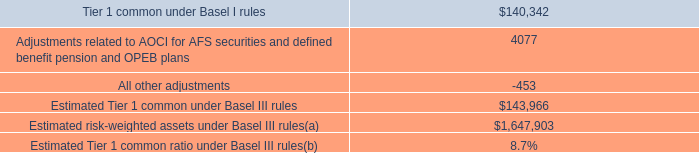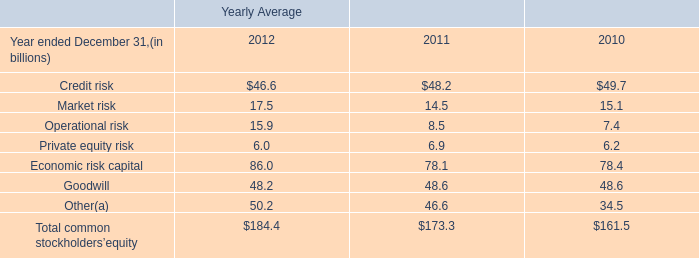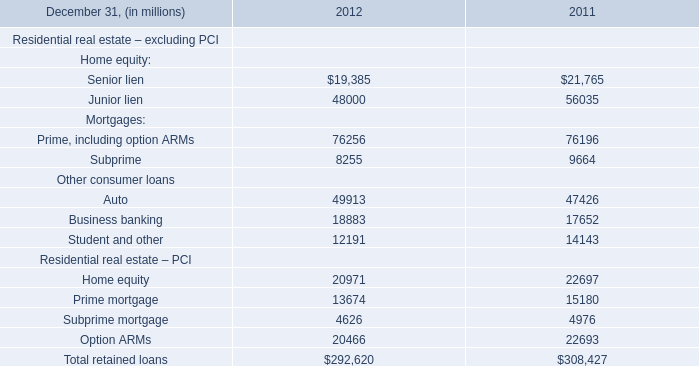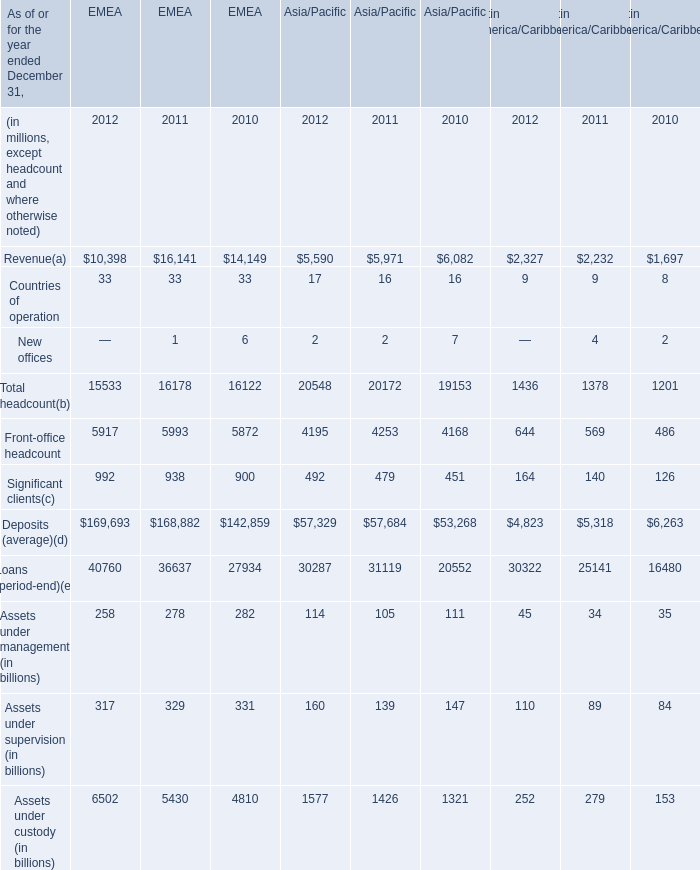how much more money would jp morgan need to meet management 2019s plan to reach an estimated basel iii tier i common ratio of 9.5%? 
Computations: ((1647903 * 9.5%) - 143966)
Answer: 12584.785. 